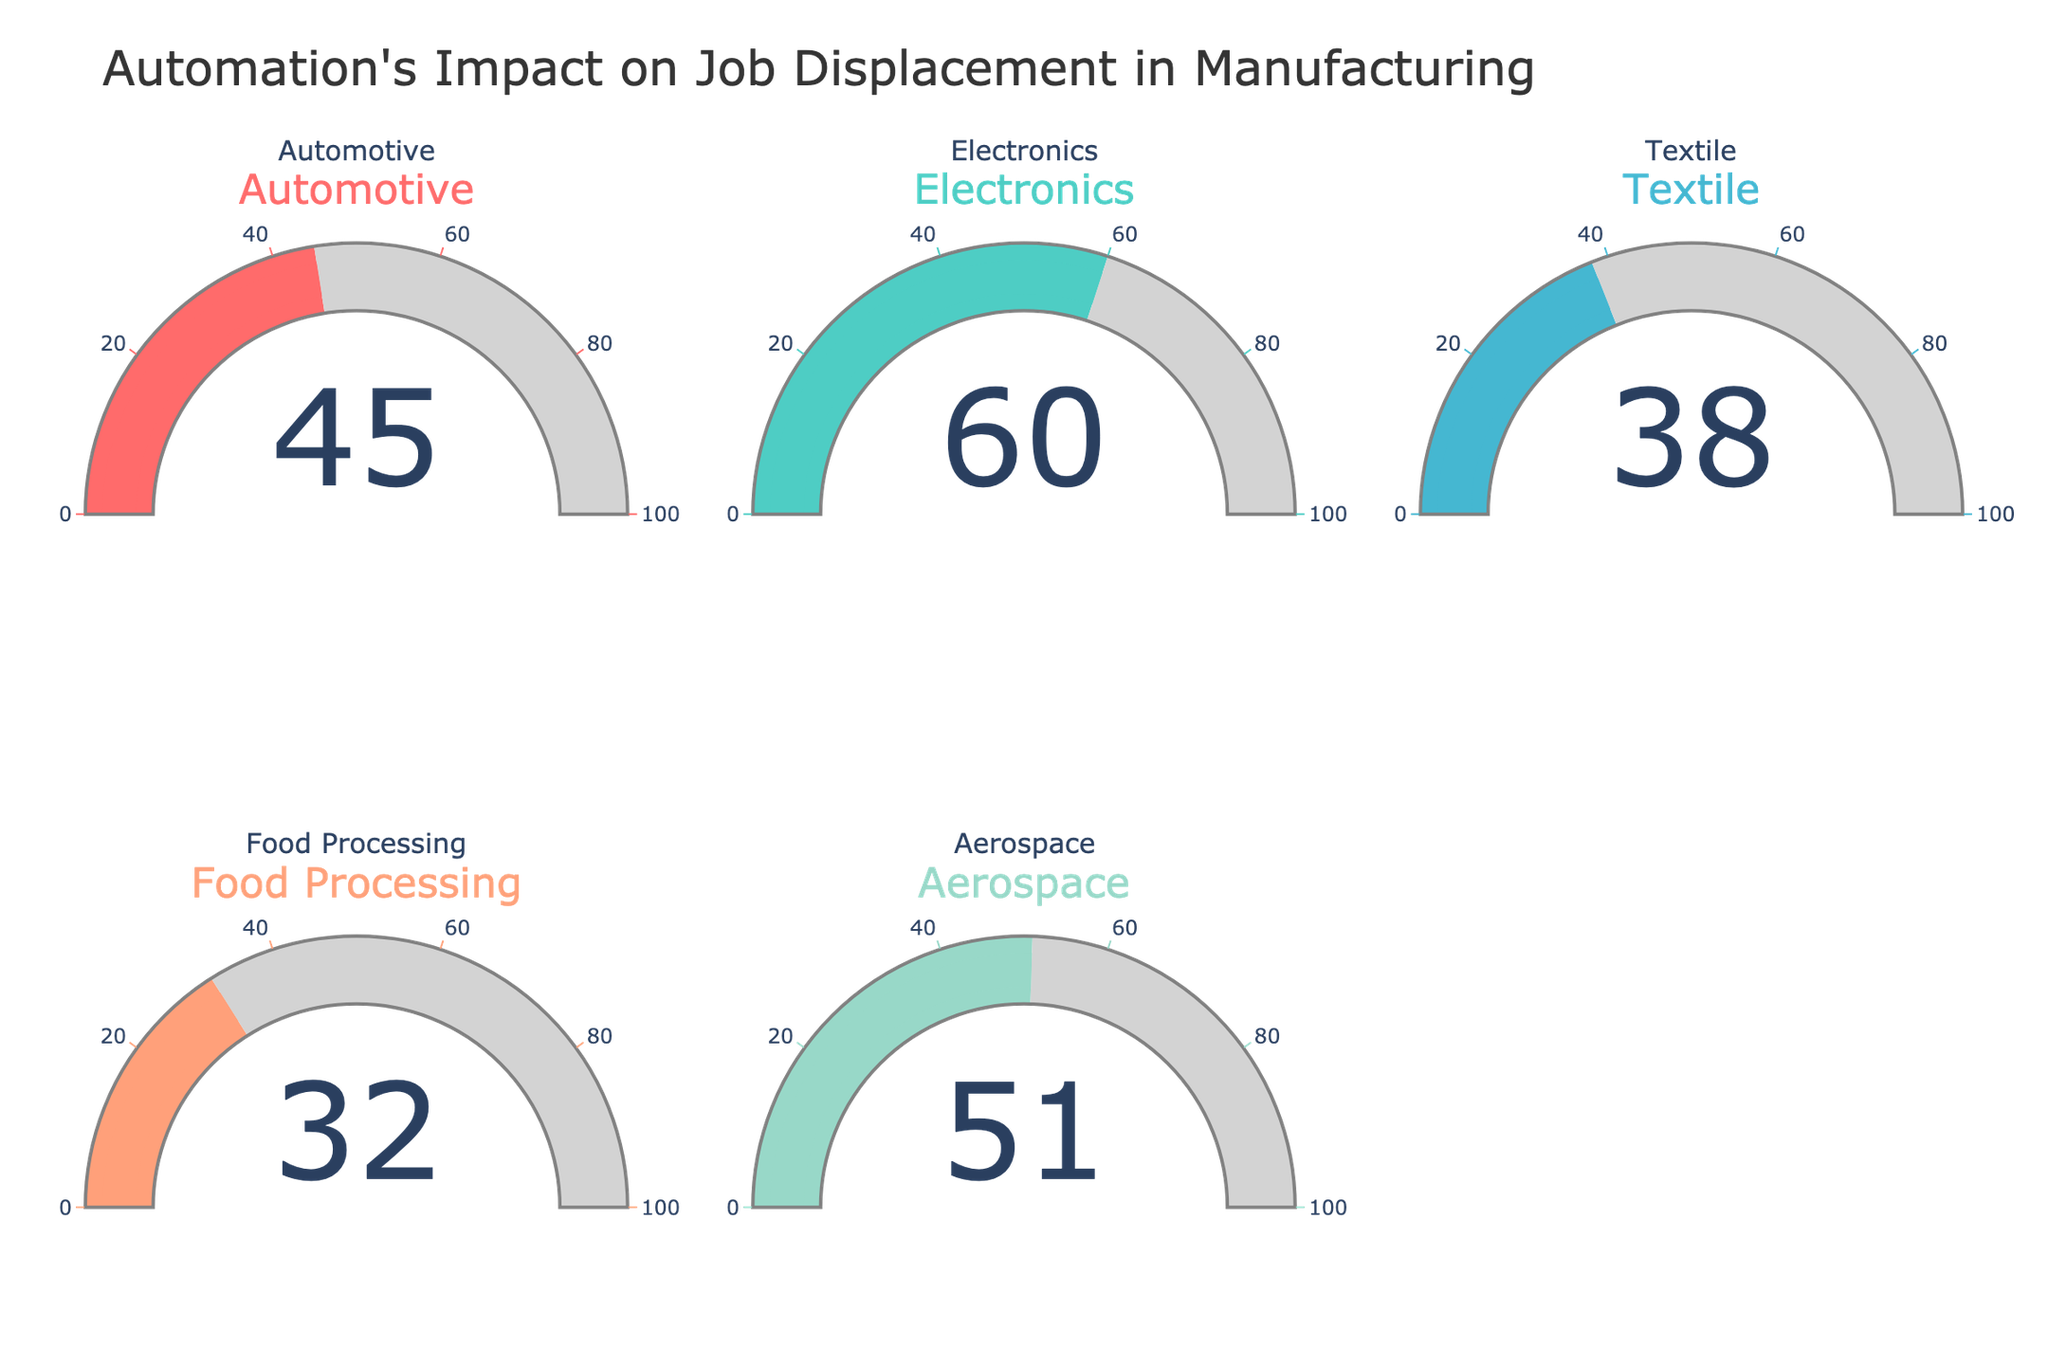what is the highest percentage of job displacement? By examining all the gauge charts, the highest percentage displayed is easily identified based on the numerical value shown.
Answer: 60 which industries have a job displacement percentage above 40%? Observe the gauge charts and identify which industries have numbers above the 40% mark. Automotive (45%), Electronics (60%), and Aerospace (51%) meet this criterion.
Answer: Automotive, Electronics, Aerospace what is the difference in job displacement percentage between electronics and textile industries? Subtract the percentage of the textile industry from the electronics industry (60% - 38%).
Answer: 22 how many industries have a job displacement percentage below the average? First, calculate the average job displacement percentage of all industries. The percentages are 45, 60, 38, 32, 51. Sum these up: 45 + 60 + 38 + 32 + 51 = 226, and divide by 5 to get the average: 226/5 = 45.2. Then count industries below this average (Textile, Food Processing).
Answer: 2 which industry has the most comparable job displacement percentage to the aerospace industry? Identify the industry with a percentage closest to the Aerospace industry (51%). Automotive (45%) is the nearest.
Answer: Automotive what is the total job displacement percentage if combining food processing and textile industries? Add the percentages of the food processing and textile industries (32% + 38%).
Answer: 70 which industry shows a slightly higher job displacement percentage than automotive? Compare the automotive percentage (45%) with other industries. Aerospace (51%) is slightly higher.
Answer: Aerospace 